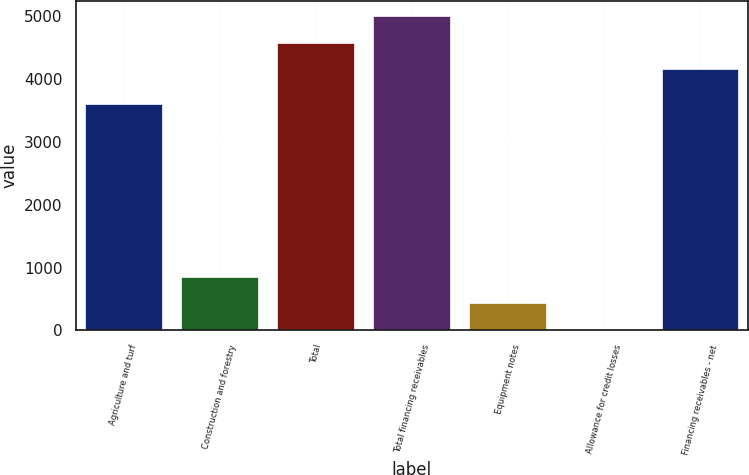<chart> <loc_0><loc_0><loc_500><loc_500><bar_chart><fcel>Agriculture and turf<fcel>Construction and forestry<fcel>Total<fcel>Total financing receivables<fcel>Equipment notes<fcel>Allowance for credit losses<fcel>Financing receivables - net<nl><fcel>3602<fcel>853<fcel>4572.5<fcel>4992<fcel>433.5<fcel>14<fcel>4153<nl></chart> 